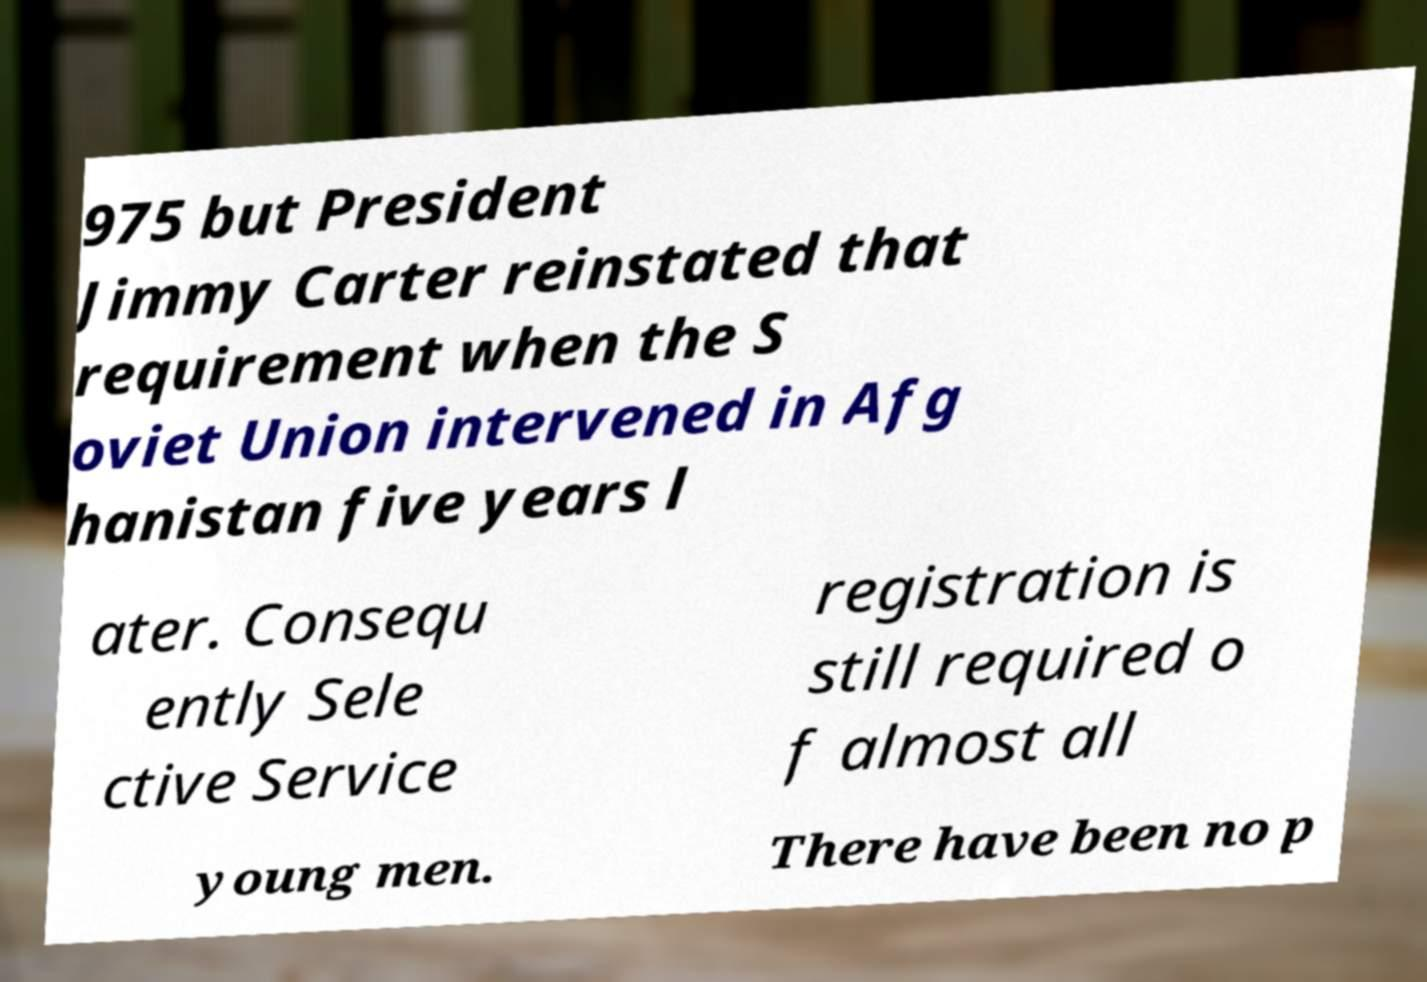What messages or text are displayed in this image? I need them in a readable, typed format. 975 but President Jimmy Carter reinstated that requirement when the S oviet Union intervened in Afg hanistan five years l ater. Consequ ently Sele ctive Service registration is still required o f almost all young men. There have been no p 